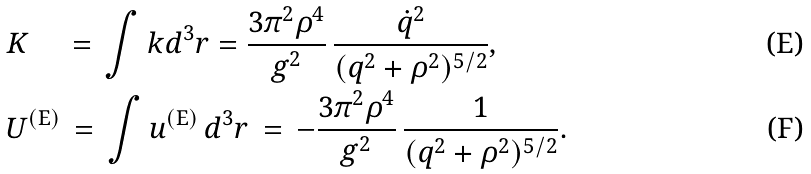Convert formula to latex. <formula><loc_0><loc_0><loc_500><loc_500>& K \quad \, = \, \int k d ^ { 3 } r = \frac { 3 \pi ^ { 2 } \rho ^ { 4 } } { g ^ { 2 } } \, \frac { \dot { q } ^ { 2 } } { ( q ^ { 2 } + \rho ^ { 2 } ) ^ { 5 / 2 } } , \\ & U ^ { ( \text {E} ) } \, = \, \int u ^ { ( \text {E} ) } \, d ^ { 3 } r \, = \, - \frac { 3 \pi ^ { 2 } \rho ^ { 4 } } { g ^ { 2 } } \, \frac { 1 } { ( q ^ { 2 } + \rho ^ { 2 } ) ^ { 5 / 2 } } .</formula> 